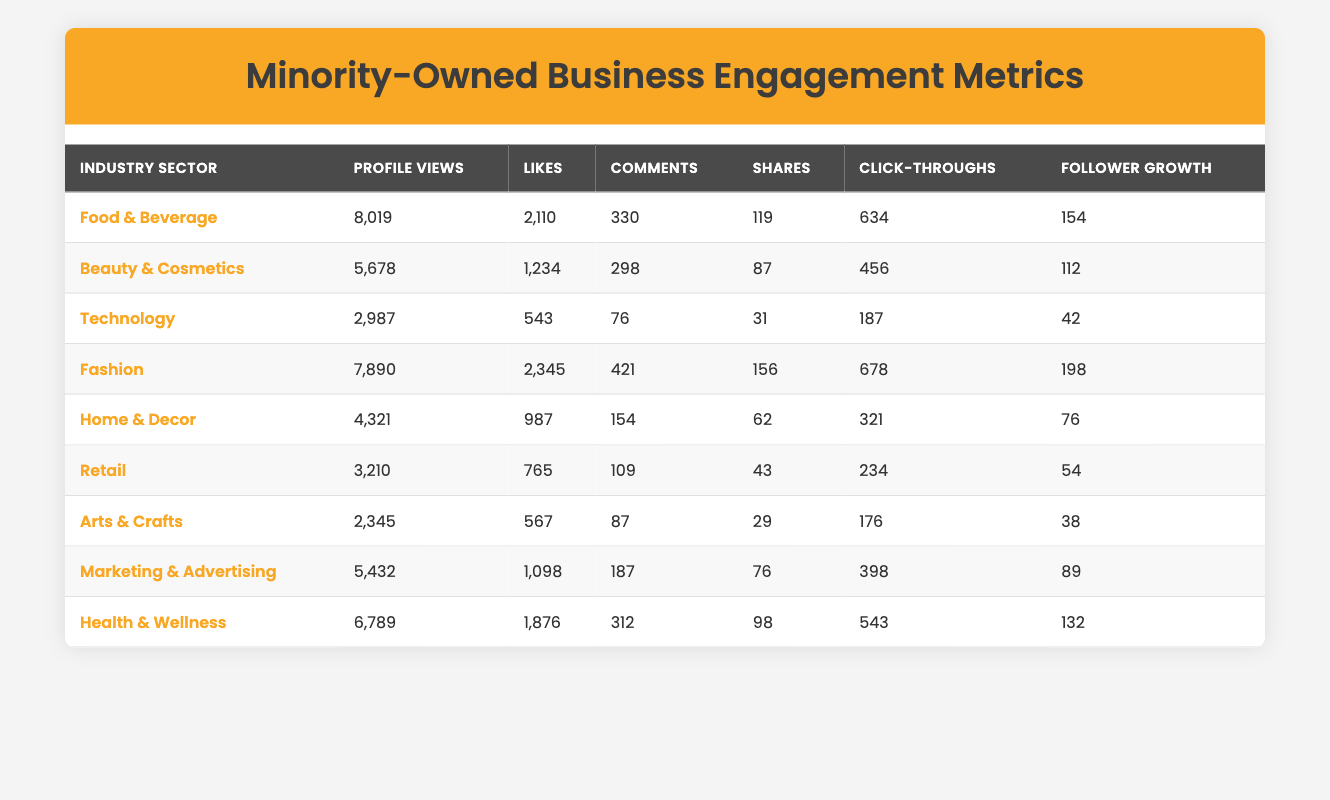What is the total number of profile views for the Food & Beverage sector? To find the total profile views in the Food & Beverage sector, we add the profile views of the businesses in this sector: Harlem Soul Food (3452) + Global Flavors Catering (4567) = 8019.
Answer: 8019 Which industry sector has the highest number of likes? To determine which industry sector has the highest likes, we compare the likes across all sectors. The Fashion sector (Latinx Threads) has 2345 likes, which is the highest number.
Answer: Fashion What is the average follower growth across all industry sectors? To calculate the average follower growth, we sum the follower growth figures: (67 + 112 + 42 + 198 + 76 + 54 + 38 + 89 + 132) = 768. Since there are 9 sectors, the average follower growth is 768 / 9 = 85.33.
Answer: 85.33 Does the Marketing & Advertising sector have more shares than the Technology sector? The Marketing & Advertising sector has 76 shares, while the Technology sector has 31 shares. Since 76 is greater than 31, the Marketing & Advertising sector does have more shares than the Technology sector.
Answer: Yes What is the total number of comments for the Arts & Crafts and Retail sectors combined? To find the total number of comments for both sectors, we add the comments from Arts & Crafts (87) and Retail (109): 87 + 109 = 196.
Answer: 196 Which sector experienced the least follower growth? Comparing the follower growth across all sectors, Indigenous Artistry has the least amount at 38, which is lower than all other sectors.
Answer: Arts & Crafts How many more profile views does the Health & Wellness sector have compared to the Retail sector? The Health & Wellness sector has 6789 profile views, and the Retail sector has 3210 profile views. To find the difference, we subtract: 6789 - 3210 = 3579.
Answer: 3579 Is the total number of clicks throughs for the Food & Beverage sector greater than the total likes for the same sector? The total number of click-throughs for the Food & Beverage sector is 634, while the total likes are 2110. Since 634 is less than 2110, the statement is false.
Answer: No What is the sum of profile views and likes for the Beauty & Cosmetics sector? For the Beauty & Cosmetics sector, we add the profile views (5678) and the likes (1234): 5678 + 1234 = 6912.
Answer: 6912 